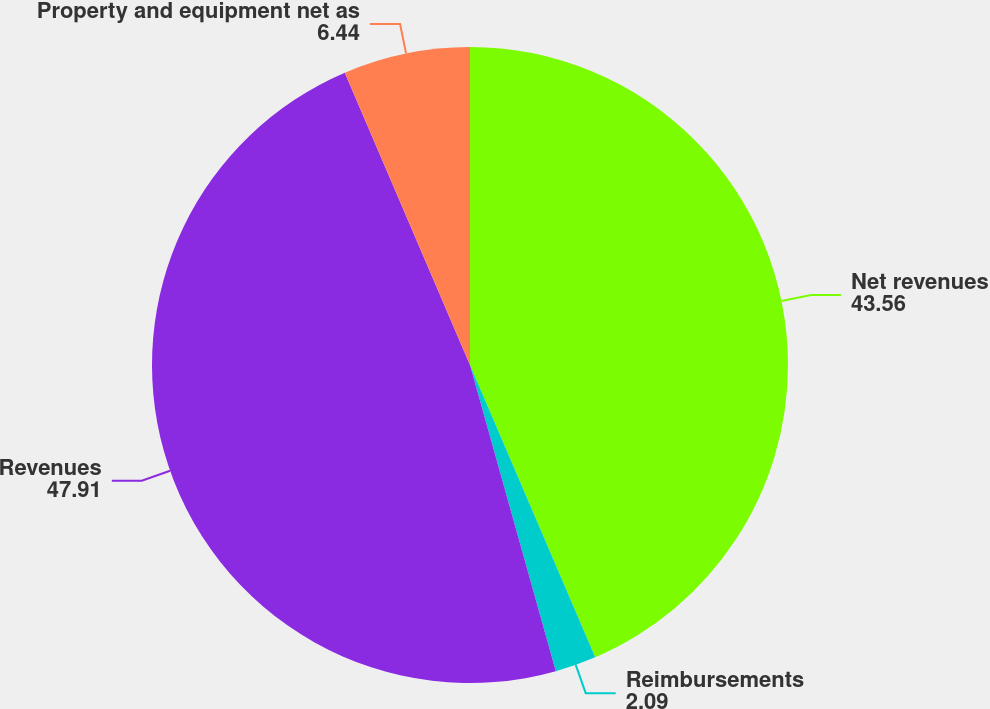<chart> <loc_0><loc_0><loc_500><loc_500><pie_chart><fcel>Net revenues<fcel>Reimbursements<fcel>Revenues<fcel>Property and equipment net as<nl><fcel>43.56%<fcel>2.09%<fcel>47.91%<fcel>6.44%<nl></chart> 